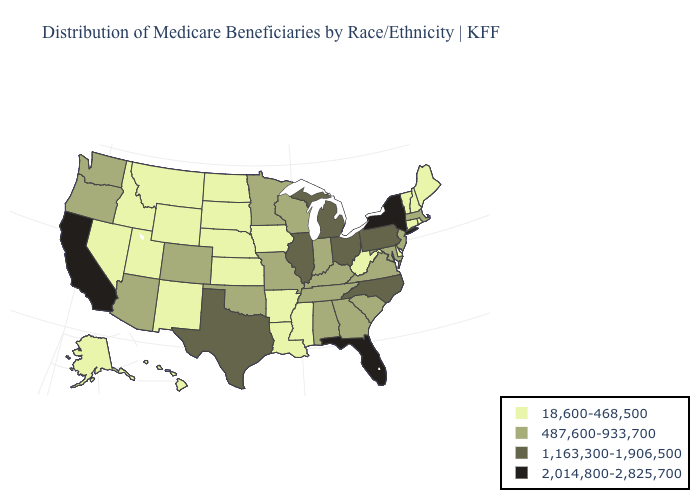Among the states that border California , which have the lowest value?
Write a very short answer. Nevada. Among the states that border Maryland , which have the lowest value?
Keep it brief. Delaware, West Virginia. Among the states that border Ohio , does Kentucky have the highest value?
Give a very brief answer. No. Name the states that have a value in the range 1,163,300-1,906,500?
Answer briefly. Illinois, Michigan, North Carolina, Ohio, Pennsylvania, Texas. Name the states that have a value in the range 2,014,800-2,825,700?
Short answer required. California, Florida, New York. Among the states that border Wisconsin , which have the highest value?
Write a very short answer. Illinois, Michigan. Does Ohio have the lowest value in the USA?
Concise answer only. No. Is the legend a continuous bar?
Keep it brief. No. What is the value of New Hampshire?
Concise answer only. 18,600-468,500. What is the value of Florida?
Keep it brief. 2,014,800-2,825,700. What is the value of Colorado?
Keep it brief. 487,600-933,700. Does Oregon have a lower value than Texas?
Give a very brief answer. Yes. What is the value of Minnesota?
Write a very short answer. 487,600-933,700. Name the states that have a value in the range 1,163,300-1,906,500?
Concise answer only. Illinois, Michigan, North Carolina, Ohio, Pennsylvania, Texas. What is the value of Nebraska?
Give a very brief answer. 18,600-468,500. 